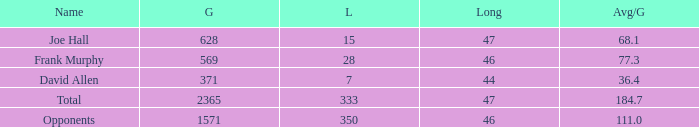Which Avg/G is the lowest one that has a Long smaller than 47, and a Name of frank murphy, and a Gain smaller than 569? None. Can you parse all the data within this table? {'header': ['Name', 'G', 'L', 'Long', 'Avg/G'], 'rows': [['Joe Hall', '628', '15', '47', '68.1'], ['Frank Murphy', '569', '28', '46', '77.3'], ['David Allen', '371', '7', '44', '36.4'], ['Total', '2365', '333', '47', '184.7'], ['Opponents', '1571', '350', '46', '111.0']]} 